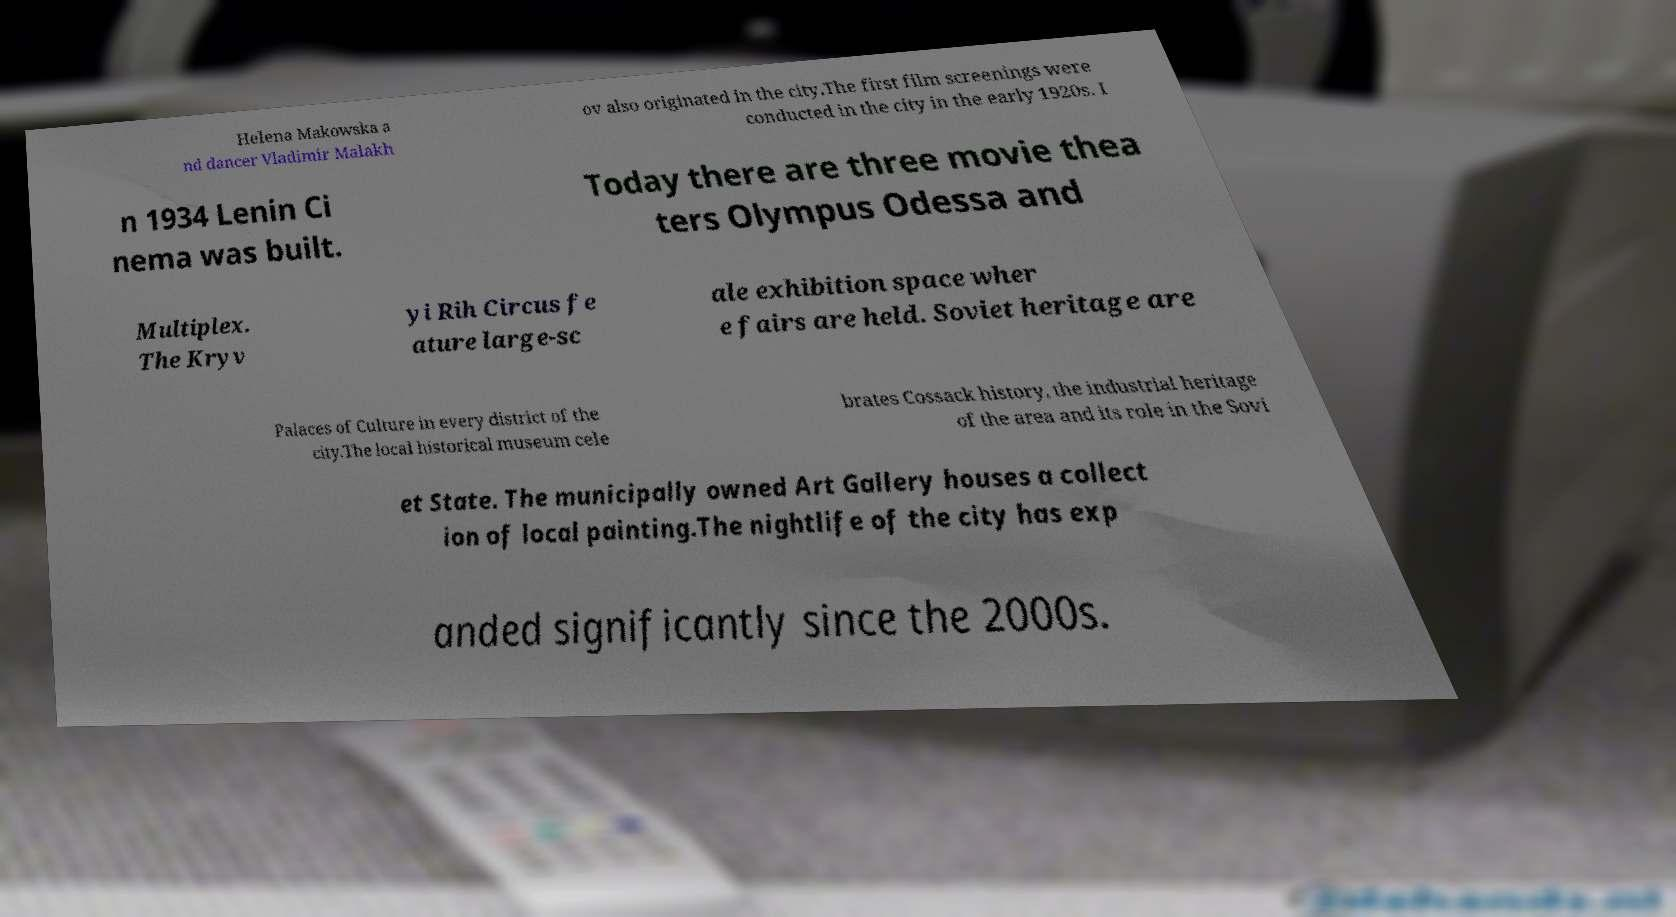Please read and relay the text visible in this image. What does it say? Helena Makowska a nd dancer Vladimir Malakh ov also originated in the city.The first film screenings were conducted in the city in the early 1920s. I n 1934 Lenin Ci nema was built. Today there are three movie thea ters Olympus Odessa and Multiplex. The Kryv yi Rih Circus fe ature large-sc ale exhibition space wher e fairs are held. Soviet heritage are Palaces of Culture in every district of the city.The local historical museum cele brates Cossack history, the industrial heritage of the area and its role in the Sovi et State. The municipally owned Art Gallery houses a collect ion of local painting.The nightlife of the city has exp anded significantly since the 2000s. 